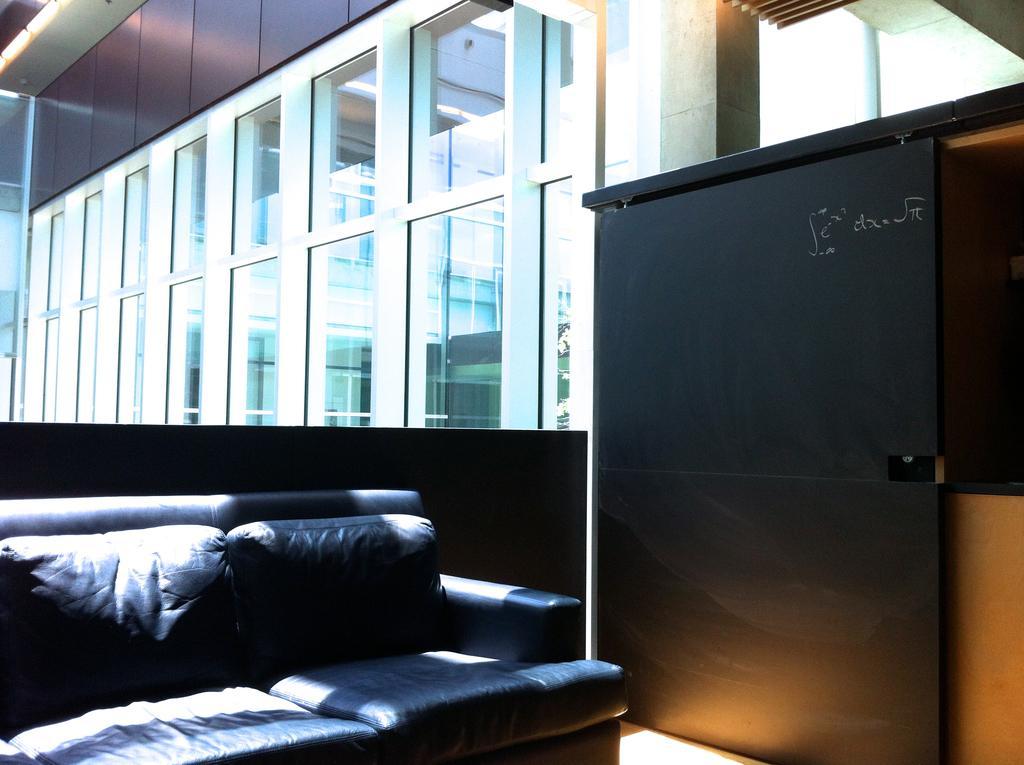Could you give a brief overview of what you see in this image? This is a picture taken in a room. In the foreground of the picture there is a couch. In the background there are glass windows, outside the window we can see the building. 